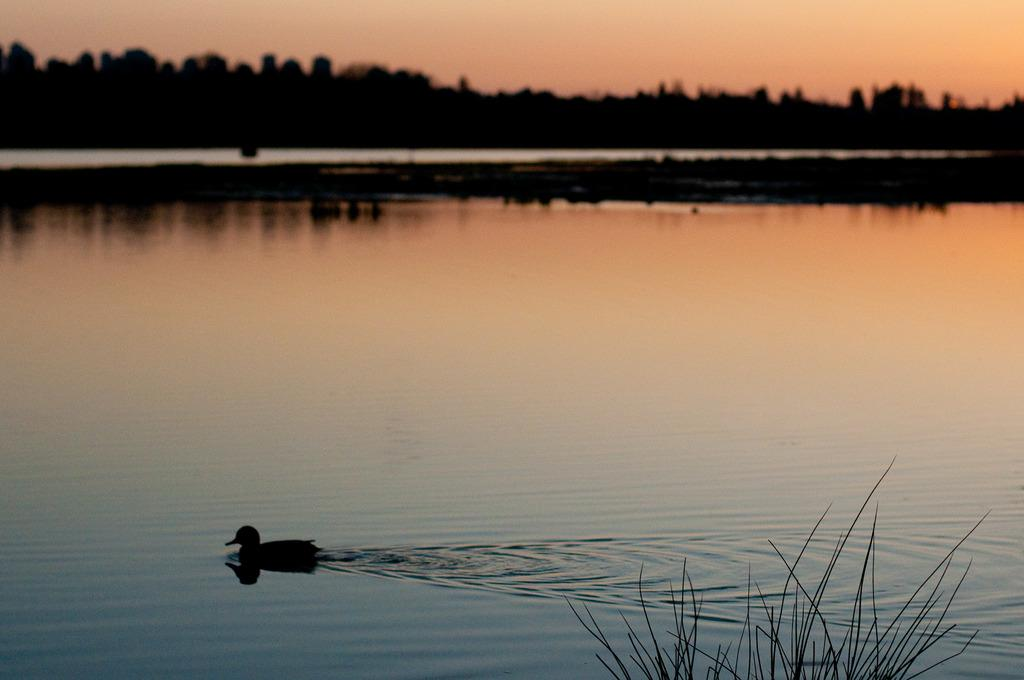What animal is present in the image? There is a duck in the image. Where is the duck located? The duck is on the water. What type of vegetation can be seen in the image? There is grass visible in the image. Can you describe the background of the image? The background of the image is blurry, but there are trees and the sky visible. What type of record is the duck holding in the image? There is no record present in the image; the duck is on the water. Is there any evidence of a crime in the image? There is no indication of a crime in the image; it features a duck on the water with a blurry background. 